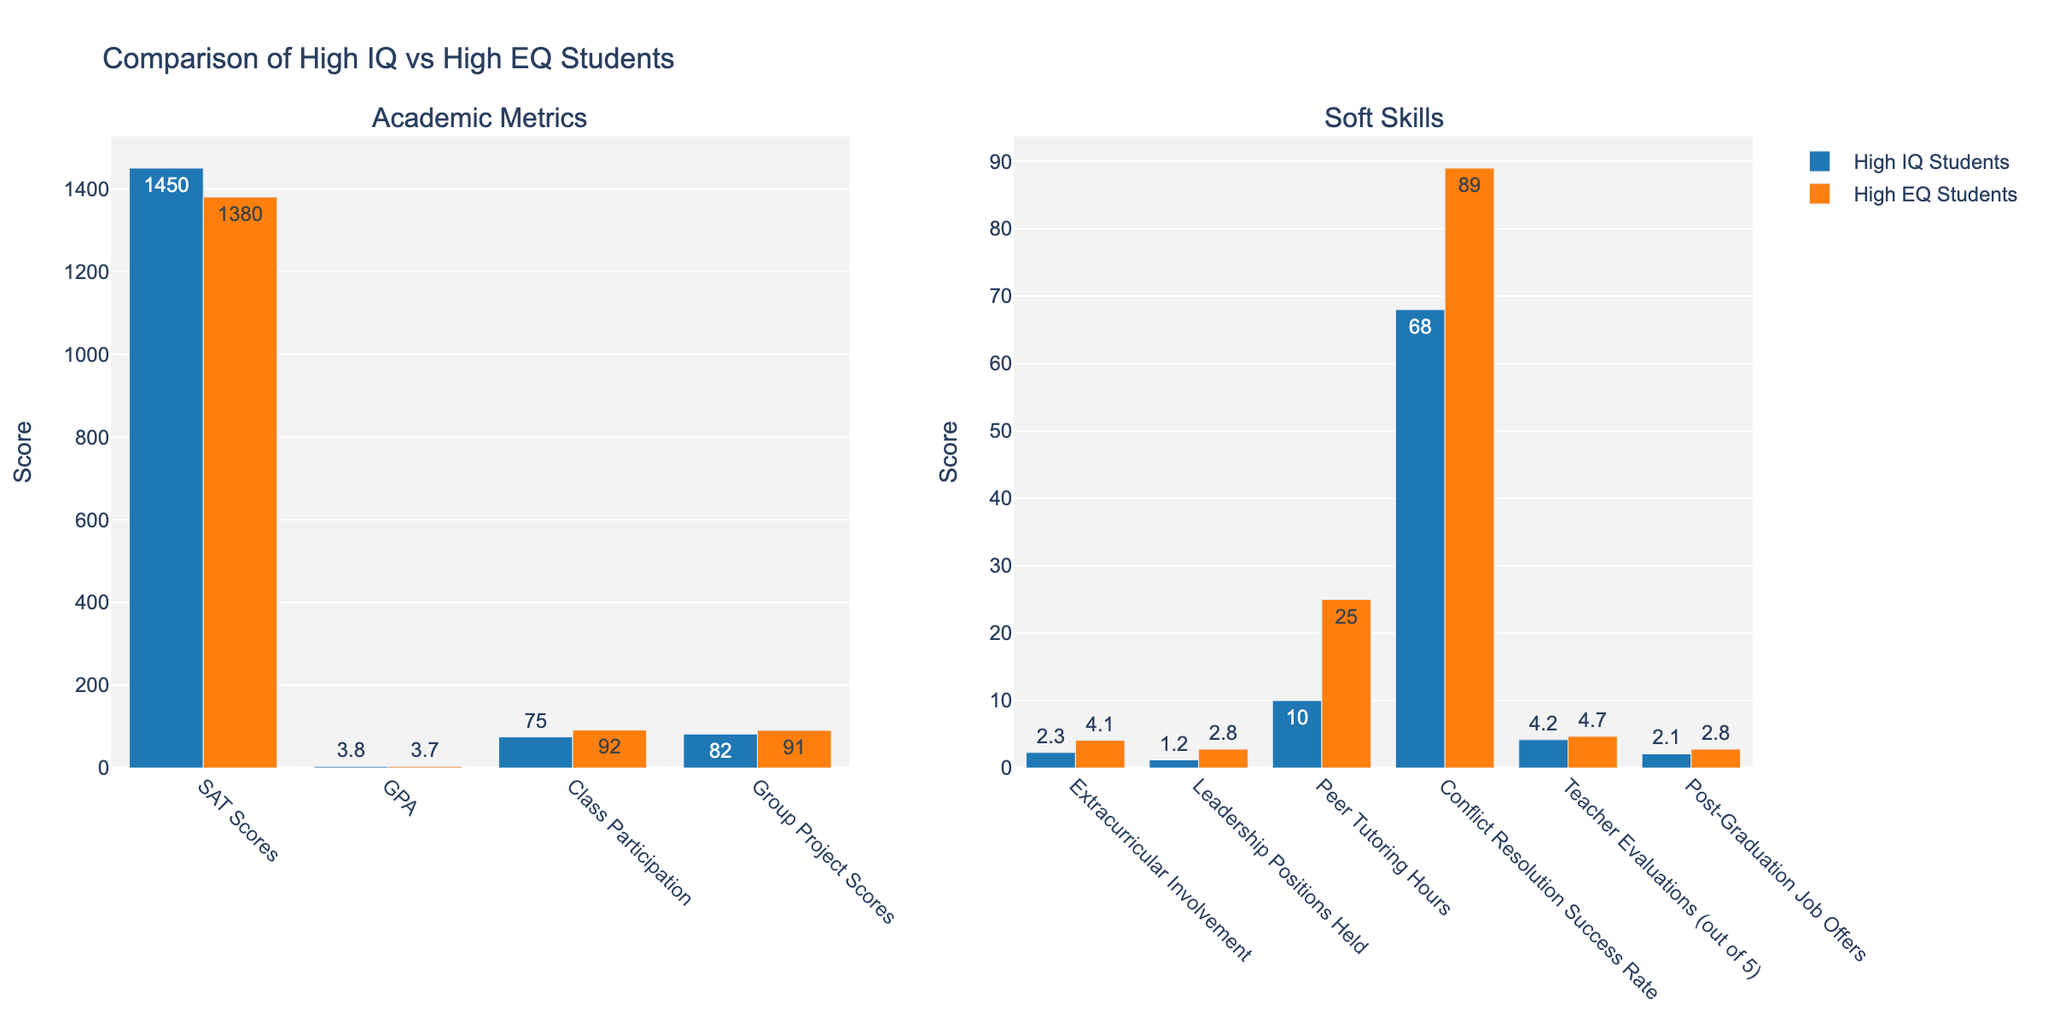What's the difference in SAT Scores between high IQ and high EQ students? To find the difference in SAT Scores, subtract the SAT score of high EQ students (1380) from the SAT score of high IQ students (1450). 1450 - 1380 = 70
Answer: 70 Which group has a higher GPA, high IQ or high EQ students? Compare the GPA value of high IQ students (3.8) with the GPA value of high EQ students (3.7). Since 3.8 > 3.7, high IQ students have a higher GPA.
Answer: High IQ students Who has greater class participation, high IQ or high EQ students? The class participation of high IQ students is 75%, while high EQ students have 92%. Since 92% > 75%, high EQ students have greater class participation.
Answer: High EQ students What is the average score of the group project scores for both high IQ and high EQ students? To find the average score, add the group project scores for high IQ (82%) and high EQ (91%) students and divide by 2. (82 + 91) / 2 = 86.5
Answer: 86.5 What is the total number of leadership positions held by both high IQ and high EQ students? Add the number of leadership positions held by high IQ students (1.2) to the number of leadership positions held by high EQ students (2.8). 1.2 + 2.8 = 4
Answer: 4 How many more hours do high EQ students spend on peer tutoring compared to high IQ students? Subtract the number of peer tutoring hours for high IQ students (10) from the number of peer tutoring hours for high EQ students (25). 25 - 10 = 15
Answer: 15 Which group has a higher success rate in conflict resolution? The conflict resolution success rate for high IQ students is 68% while for high EQ students it is 89%. Since 89% > 68%, high EQ students have a higher success rate.
Answer: High EQ students How much higher are teacher evaluations for high EQ students compared to high IQ students? Subtract the teacher evaluation score for high IQ students (4.2) from the score for high EQ students (4.7). 4.7 - 4.2 = 0.5
Answer: 0.5 By how much do high EQ students lead in post-graduation job offers compared to high IQ students? Subtract the number of post-graduation job offers for high IQ students (2.1) from those for high EQ students (2.8). 2.8 - 2.1 = 0.7
Answer: 0.7 Which group excels more in extracurricular involvement? Compare the extracurricular involvement score of high IQ students (2.3) with the score of high EQ students (4.1). Since 4.1 > 2.3, high EQ students excel more in extracurricular involvement.
Answer: High EQ students 